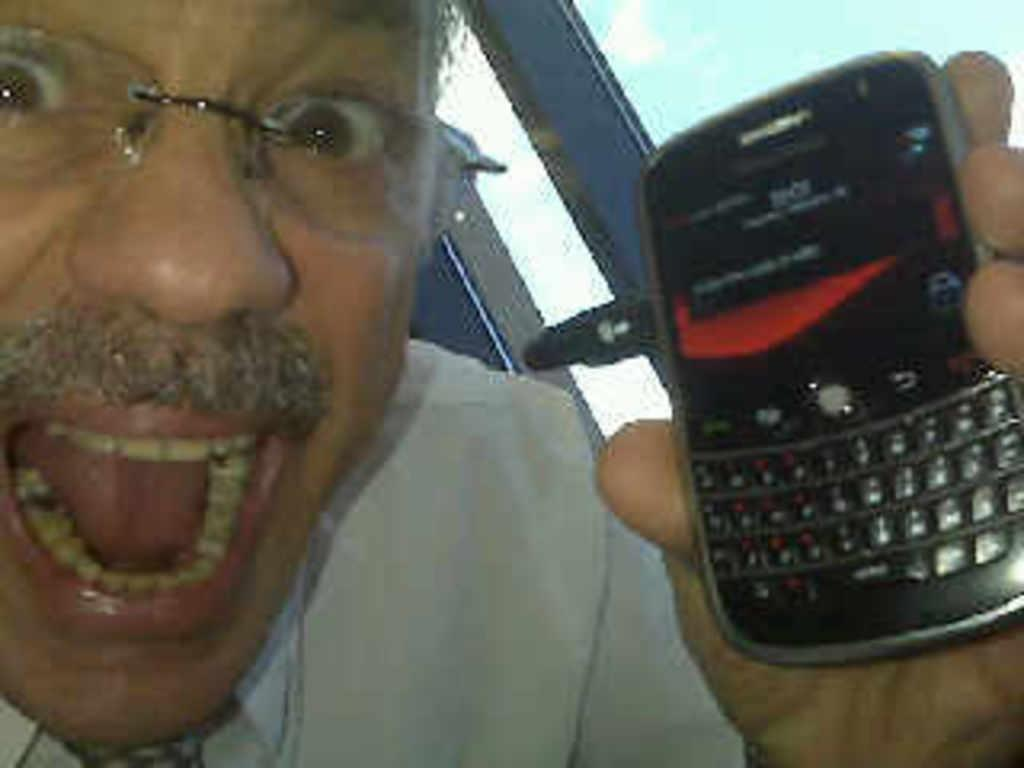Who is present in the image? There is a man in the image. What is the man wearing? The man is wearing spectacles. What is the man holding in the image? The man is holding a mobile. What is the man doing in the image? The man is shouting. What can be seen through the window in the image? There is a window in the image, but the view through it is not mentioned in the facts. What type of ghost can be seen in the image? There is no ghost present in the image. What game is the man playing in the image? The facts do not mention any games or playtime activities in the image. 